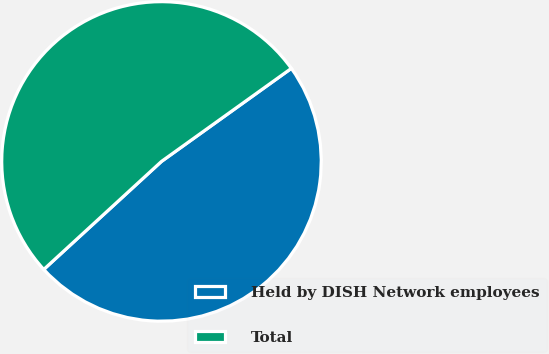Convert chart to OTSL. <chart><loc_0><loc_0><loc_500><loc_500><pie_chart><fcel>Held by DISH Network employees<fcel>Total<nl><fcel>48.08%<fcel>51.92%<nl></chart> 